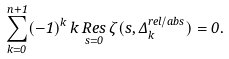Convert formula to latex. <formula><loc_0><loc_0><loc_500><loc_500>\sum _ { k = 0 } ^ { n + 1 } ( - 1 ) ^ { k } \, k \, \underset { s = 0 } { R e s } \, \zeta ( s , \Delta _ { k } ^ { r e l / a b s } ) = 0 .</formula> 